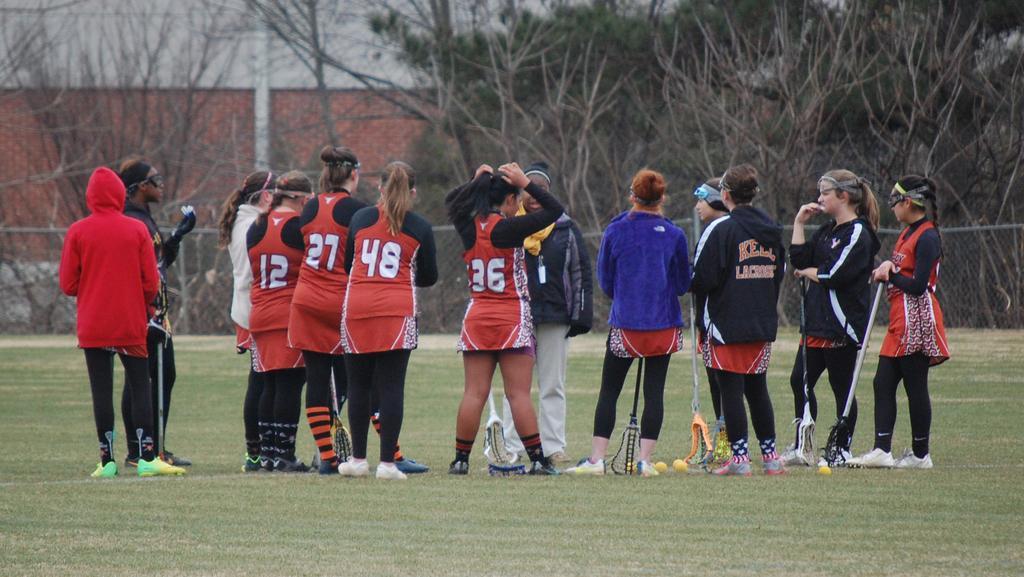Please provide a concise description of this image. In this image in the center there are a group of people who are standing, at the bottom there is grass and in the background there is a wall trees fence and pole. 